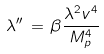Convert formula to latex. <formula><loc_0><loc_0><loc_500><loc_500>\lambda ^ { \prime \prime } \, = \, \beta \frac { \lambda ^ { 2 } v ^ { 4 } } { M _ { p } ^ { 4 } }</formula> 